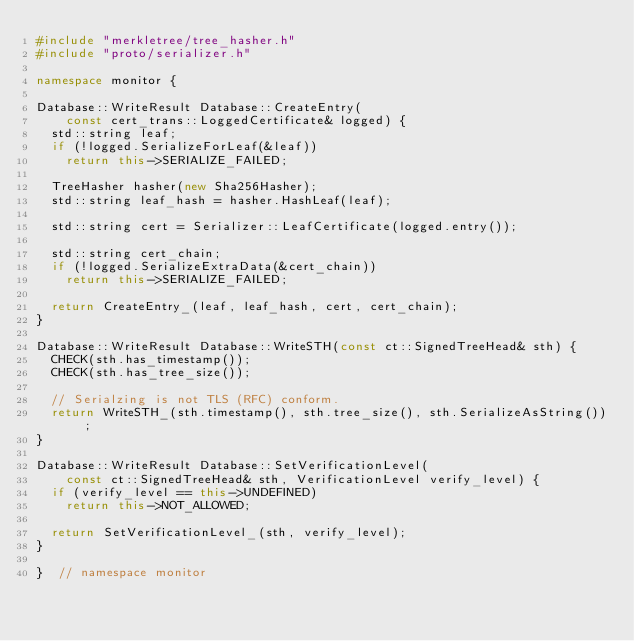<code> <loc_0><loc_0><loc_500><loc_500><_C++_>#include "merkletree/tree_hasher.h"
#include "proto/serializer.h"

namespace monitor {

Database::WriteResult Database::CreateEntry(
    const cert_trans::LoggedCertificate& logged) {
  std::string leaf;
  if (!logged.SerializeForLeaf(&leaf))
    return this->SERIALIZE_FAILED;

  TreeHasher hasher(new Sha256Hasher);
  std::string leaf_hash = hasher.HashLeaf(leaf);

  std::string cert = Serializer::LeafCertificate(logged.entry());

  std::string cert_chain;
  if (!logged.SerializeExtraData(&cert_chain))
    return this->SERIALIZE_FAILED;

  return CreateEntry_(leaf, leaf_hash, cert, cert_chain);
}

Database::WriteResult Database::WriteSTH(const ct::SignedTreeHead& sth) {
  CHECK(sth.has_timestamp());
  CHECK(sth.has_tree_size());

  // Serialzing is not TLS (RFC) conform.
  return WriteSTH_(sth.timestamp(), sth.tree_size(), sth.SerializeAsString());
}

Database::WriteResult Database::SetVerificationLevel(
    const ct::SignedTreeHead& sth, VerificationLevel verify_level) {
  if (verify_level == this->UNDEFINED)
    return this->NOT_ALLOWED;

  return SetVerificationLevel_(sth, verify_level);
}

}  // namespace monitor
</code> 